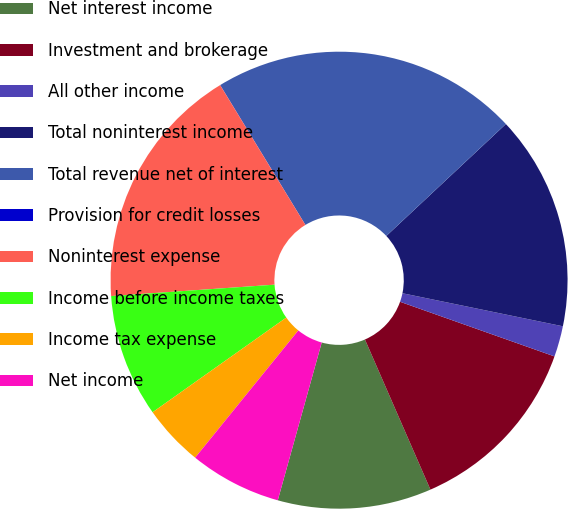<chart> <loc_0><loc_0><loc_500><loc_500><pie_chart><fcel>Net interest income<fcel>Investment and brokerage<fcel>All other income<fcel>Total noninterest income<fcel>Total revenue net of interest<fcel>Provision for credit losses<fcel>Noninterest expense<fcel>Income before income taxes<fcel>Income tax expense<fcel>Net income<nl><fcel>10.87%<fcel>13.04%<fcel>2.18%<fcel>15.21%<fcel>21.73%<fcel>0.01%<fcel>17.39%<fcel>8.7%<fcel>4.35%<fcel>6.52%<nl></chart> 